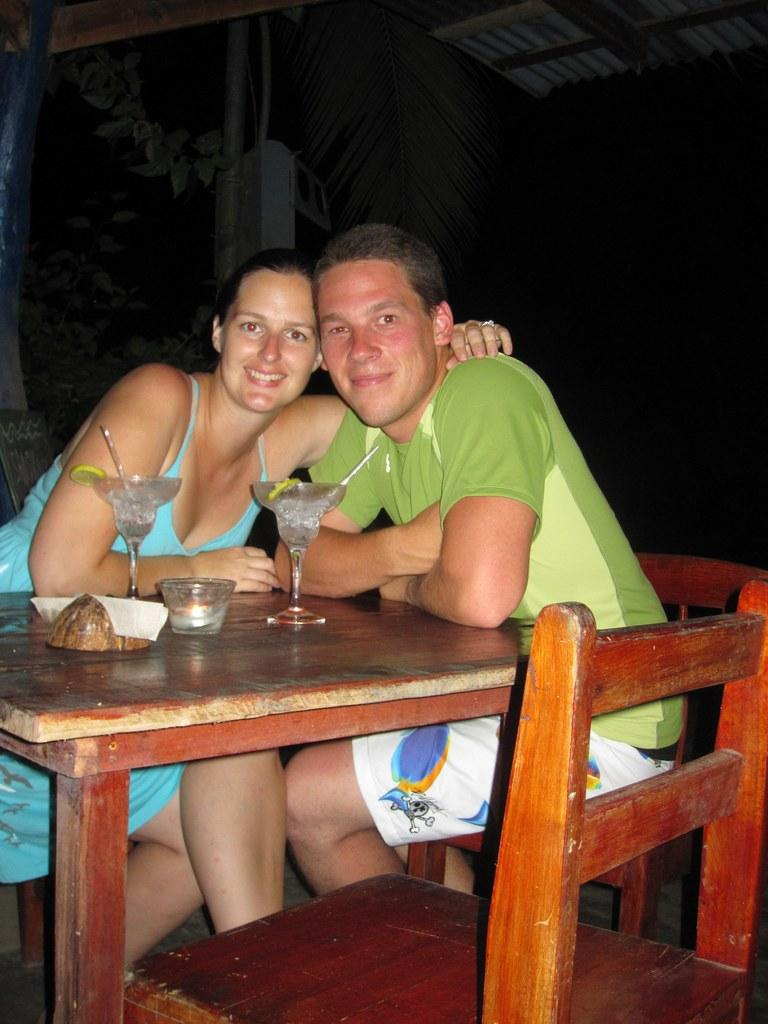How many people are in the image? There are two people in the image, a man and a woman. What are the man and woman doing in the image? Both the man and woman are seated on chairs. What objects can be seen on the table in the image? There are wine glasses and a bowl on the table. What type of vest is the grandmother wearing in the image? There is no grandmother present in the image, nor is there a vest visible. 